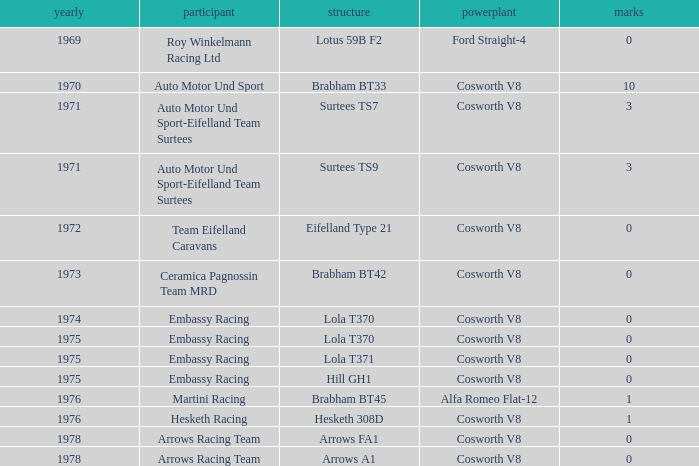In 1970, what entrant had a cosworth v8 engine? Auto Motor Und Sport. 